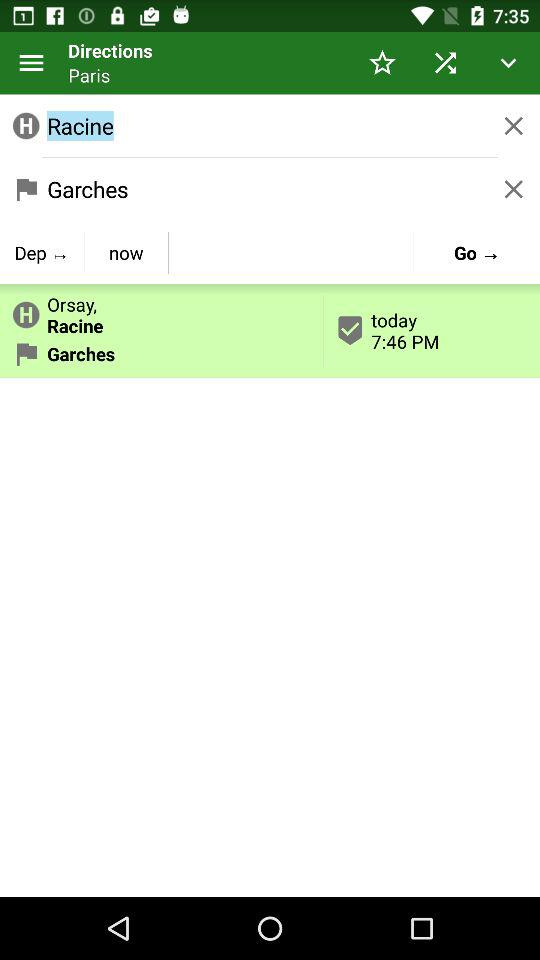What is the destination? The destination is Garches. 